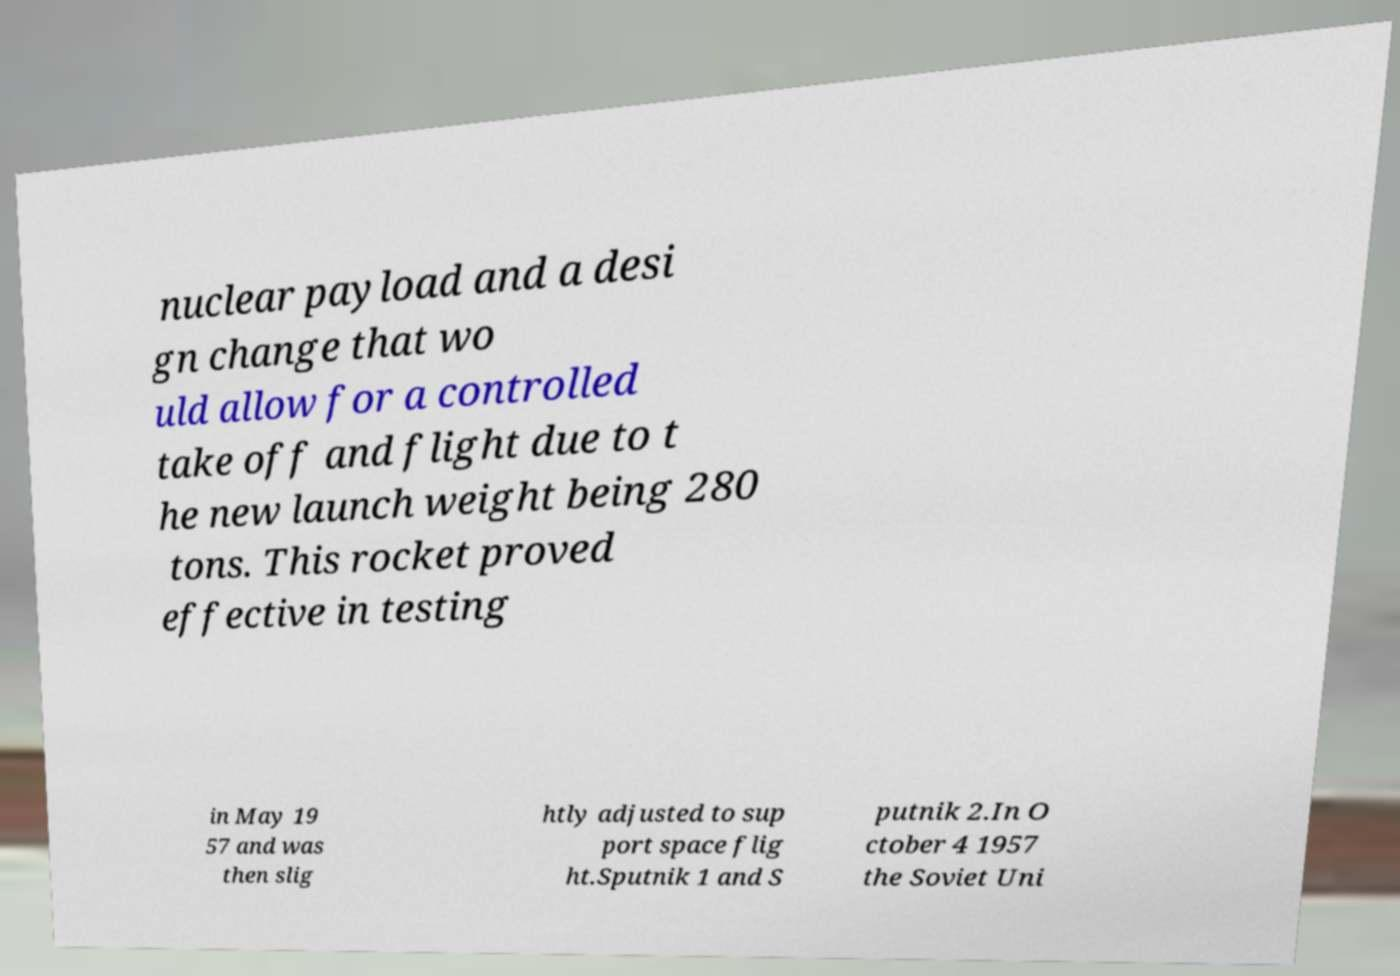What messages or text are displayed in this image? I need them in a readable, typed format. nuclear payload and a desi gn change that wo uld allow for a controlled take off and flight due to t he new launch weight being 280 tons. This rocket proved effective in testing in May 19 57 and was then slig htly adjusted to sup port space flig ht.Sputnik 1 and S putnik 2.In O ctober 4 1957 the Soviet Uni 